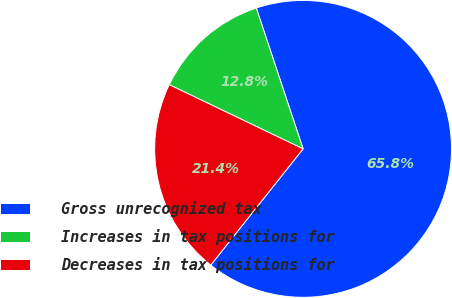<chart> <loc_0><loc_0><loc_500><loc_500><pie_chart><fcel>Gross unrecognized tax<fcel>Increases in tax positions for<fcel>Decreases in tax positions for<nl><fcel>65.79%<fcel>12.78%<fcel>21.43%<nl></chart> 